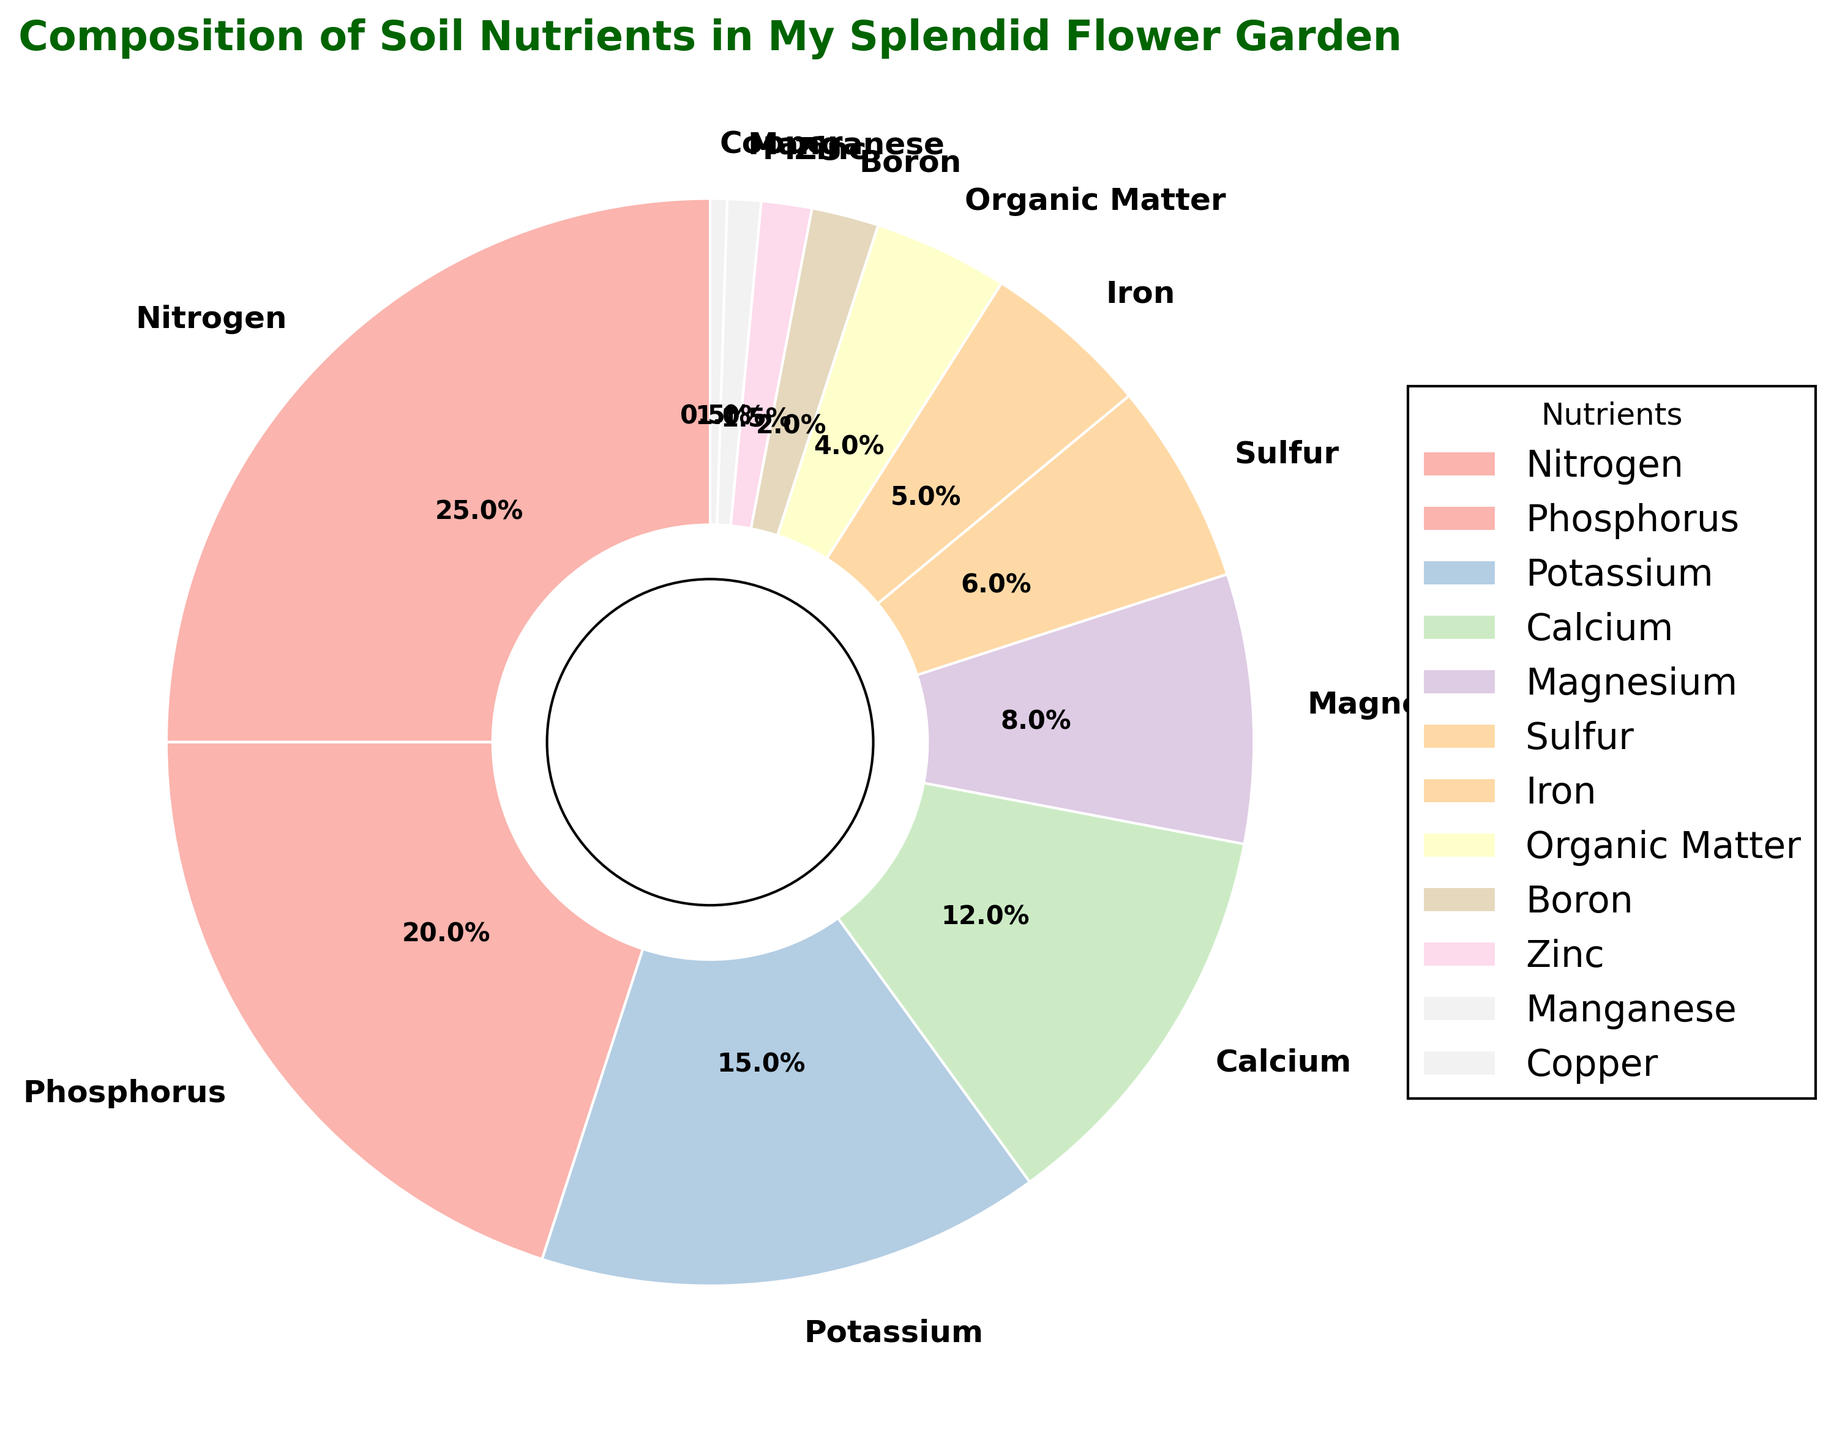What percentage of the soil nutrients does Nitrogen contribute? Nitrogen contributes a certain percentage to the overall soil nutrients, and its value can be directly seen from the pie chart. It is represented as "25%" on the chart.
Answer: 25% How much more does Phosphorus contribute compared to Magnesium? Phosphorus and Magnesium contribute specific percentages to the soil nutrients, which can be seen on the pie chart as 20% and 8%, respectively. The difference is calculated by subtracting the contribution of Magnesium from that of Phosphorus (20% - 8%).
Answer: 12% What is the combined percentage of Potassium, Sulfur, and Iron in the soil nutrients? Potassium, Sulfur, and Iron have specific percentages which can be seen on the pie chart as 15%, 6%, and 5% respectively. The combined percentage is achieved by summing these values (15% + 6% + 5%).
Answer: 26% Which nutrient has the lowest contribution to the soil nutrients? By examining the pie chart, the nutrient with the smallest percentage can be identified. Copper is shown with a contribution of 0.5%, which is the lowest among all nutrients listed.
Answer: Copper How does the contribution of Calcium compare to that of Organic Matter? The pie chart shows the percentages for both Calcium (12%) and Organic Matter (4%). To compare, we note that Calcium contributes more than Organic Matter. The difference can also be computed (12% - 4%).
Answer: Calcium contributes 8% more What percentage of the soil nutrients is made up by Micronutrients (Iron, Boron, Zinc, Manganese, and Copper)? Iron, Boron, Zinc, Manganese, and Copper have percentages shown on the pie chart as 5%, 2%, 1.5%, 1%, and 0.5%, respectively. Adding these values (5% + 2% + 1.5% + 1% + 0.5%) gives the total percentage contributed by Micronutrients.
Answer: 10% Which has a greater percentage, Sulfur or Magnesium, and by how much? The pie chart indicates the percentages of Sulfur (6%) and Magnesium (8%). Magnesium has a greater percentage. The difference is calculated by subtracting the Sulfur percentage from the Magnesium percentage (8% - 6%).
Answer: Magnesium by 2% What is the total percentage of major nutrients (Nitrogen, Phosphorus, Potassium)? Nitrogen, Phosphorus, and Potassium are represented with their respective percentages in the pie chart (25%, 20%, and 15%). Summing these values gives the total percentage of major nutrients in the soil (25% + 20% + 15%).
Answer: 60% What color represents Sulfur on the pie chart? The pie chart uses specific colors to represent each nutrient. By identifying Sulfur on the chart, the color associated with it can be observed.
Answer: Light yellowish segment Which two nutrients together make up exactly 30% of the soil nutrients? By examining the values on the pie chart, Phosphorus (20%) and Magnesium (8%) together make up 28%, while Potassium (15%) and Sulfur (6%) together make up 21%. The two that exactly make up 30% are Nitrogen (25%) and Iron (5%).
Answer: Nitrogen and Iron 